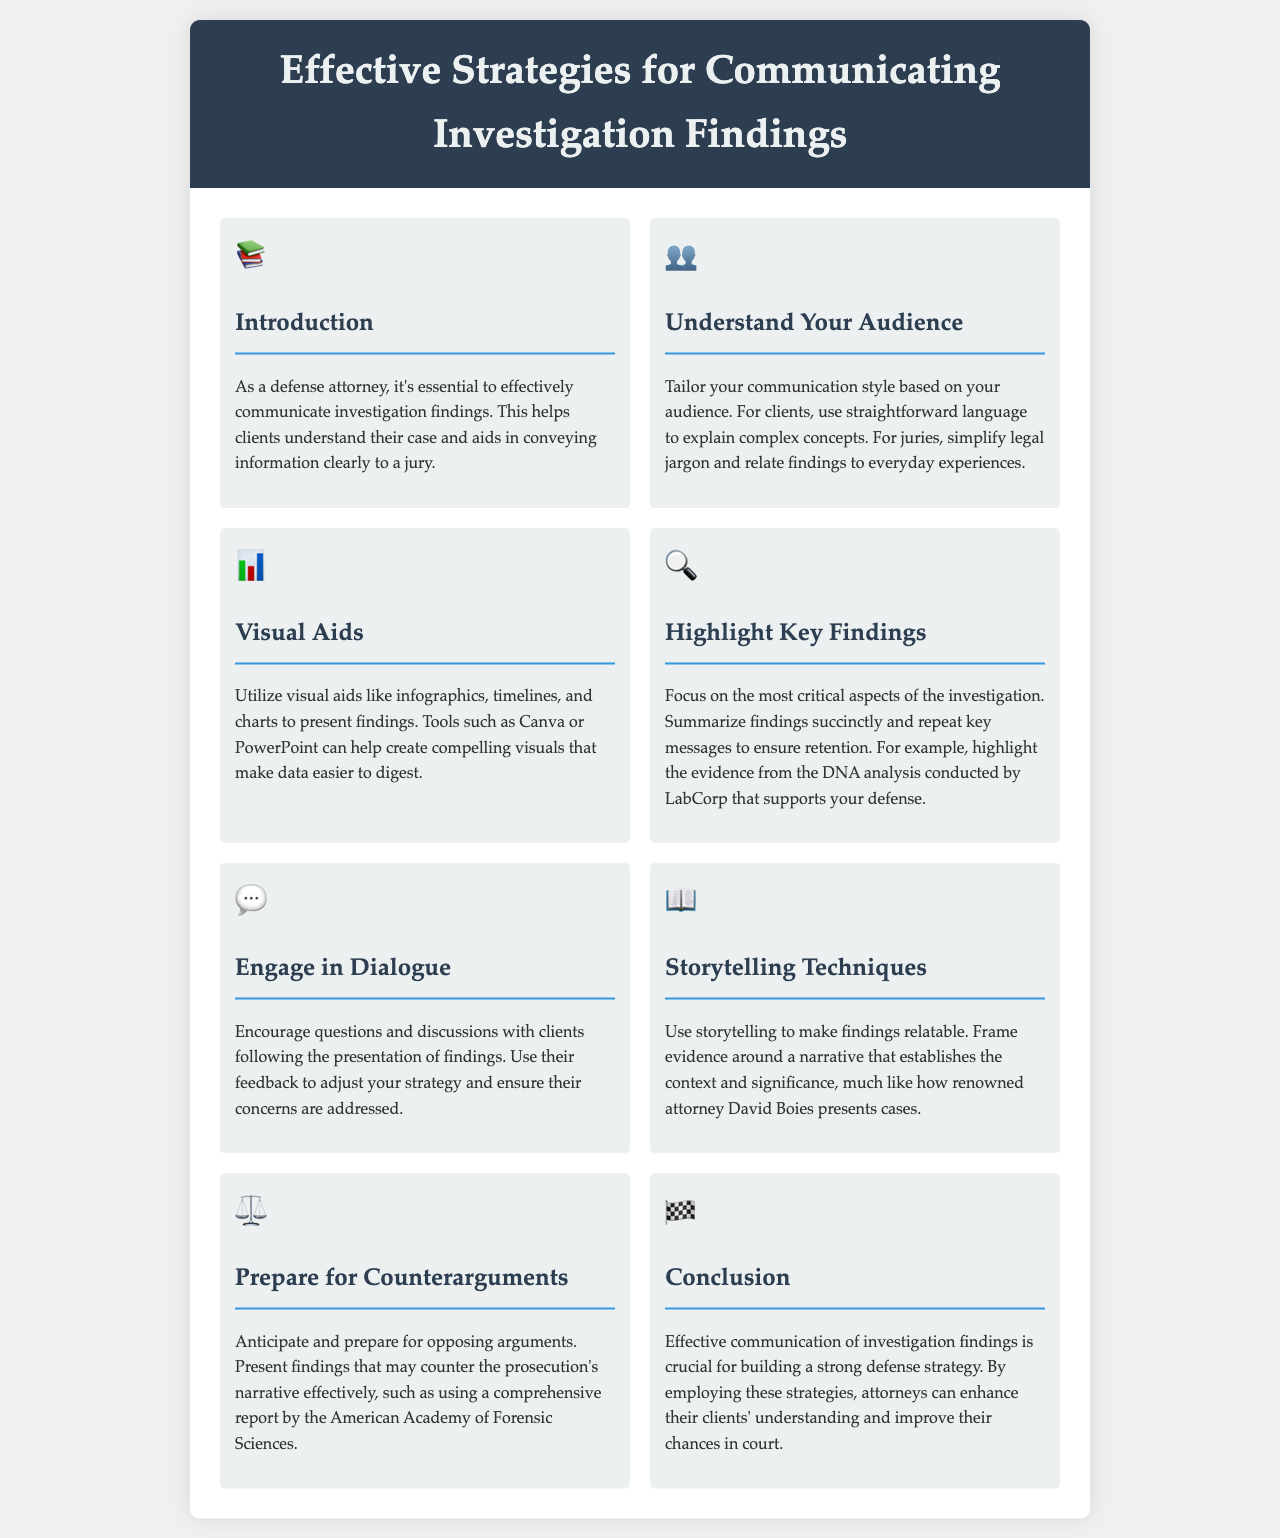What is the title of the document? The title of the document is provided in the header section of the brochure.
Answer: Effective Strategies for Communicating Investigation Findings What is mentioned as essential for communication? The introduction section outlines the importance of effective communication for defense attorneys.
Answer: Effective communication What should you tailor based on your audience? The document specifies that you need to adjust how you convey information depending on whether you are speaking to clients or juries.
Answer: Communication style Which tool is suggested for creating visual aids? The document suggests using a specific tool to create compelling visuals for presenting findings.
Answer: Canva What technique can make findings more relatable? The brochure emphasizes using a particular technique that helps in framing evidence around a narrative.
Answer: Storytelling What is a key strategy to encourage client interaction? The engagement section discusses the importance of promoting specific client actions after presenting findings.
Answer: Dialogue Which organization’s report is mentioned to prepare for counterarguments? The document references a particular organization whose report can assist in countering opposing arguments.
Answer: American Academy of Forensic Sciences What is the purpose of highlighting key findings? The document explains that focusing on critical aspects of the investigation allows for better retention of information.
Answer: Ensure retention 